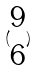Convert formula to latex. <formula><loc_0><loc_0><loc_500><loc_500>( \begin{matrix} 9 \\ 6 \end{matrix} )</formula> 